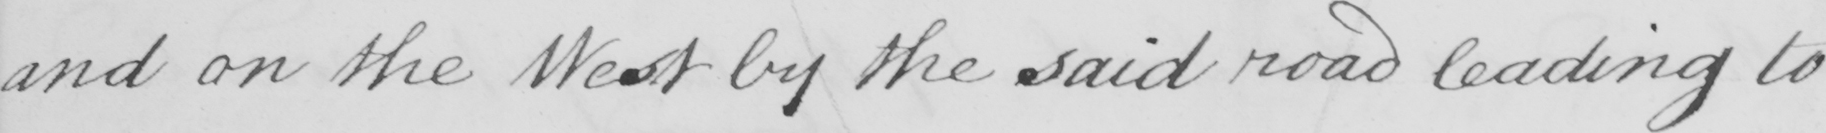Can you read and transcribe this handwriting? and on the West by the said road leading to 